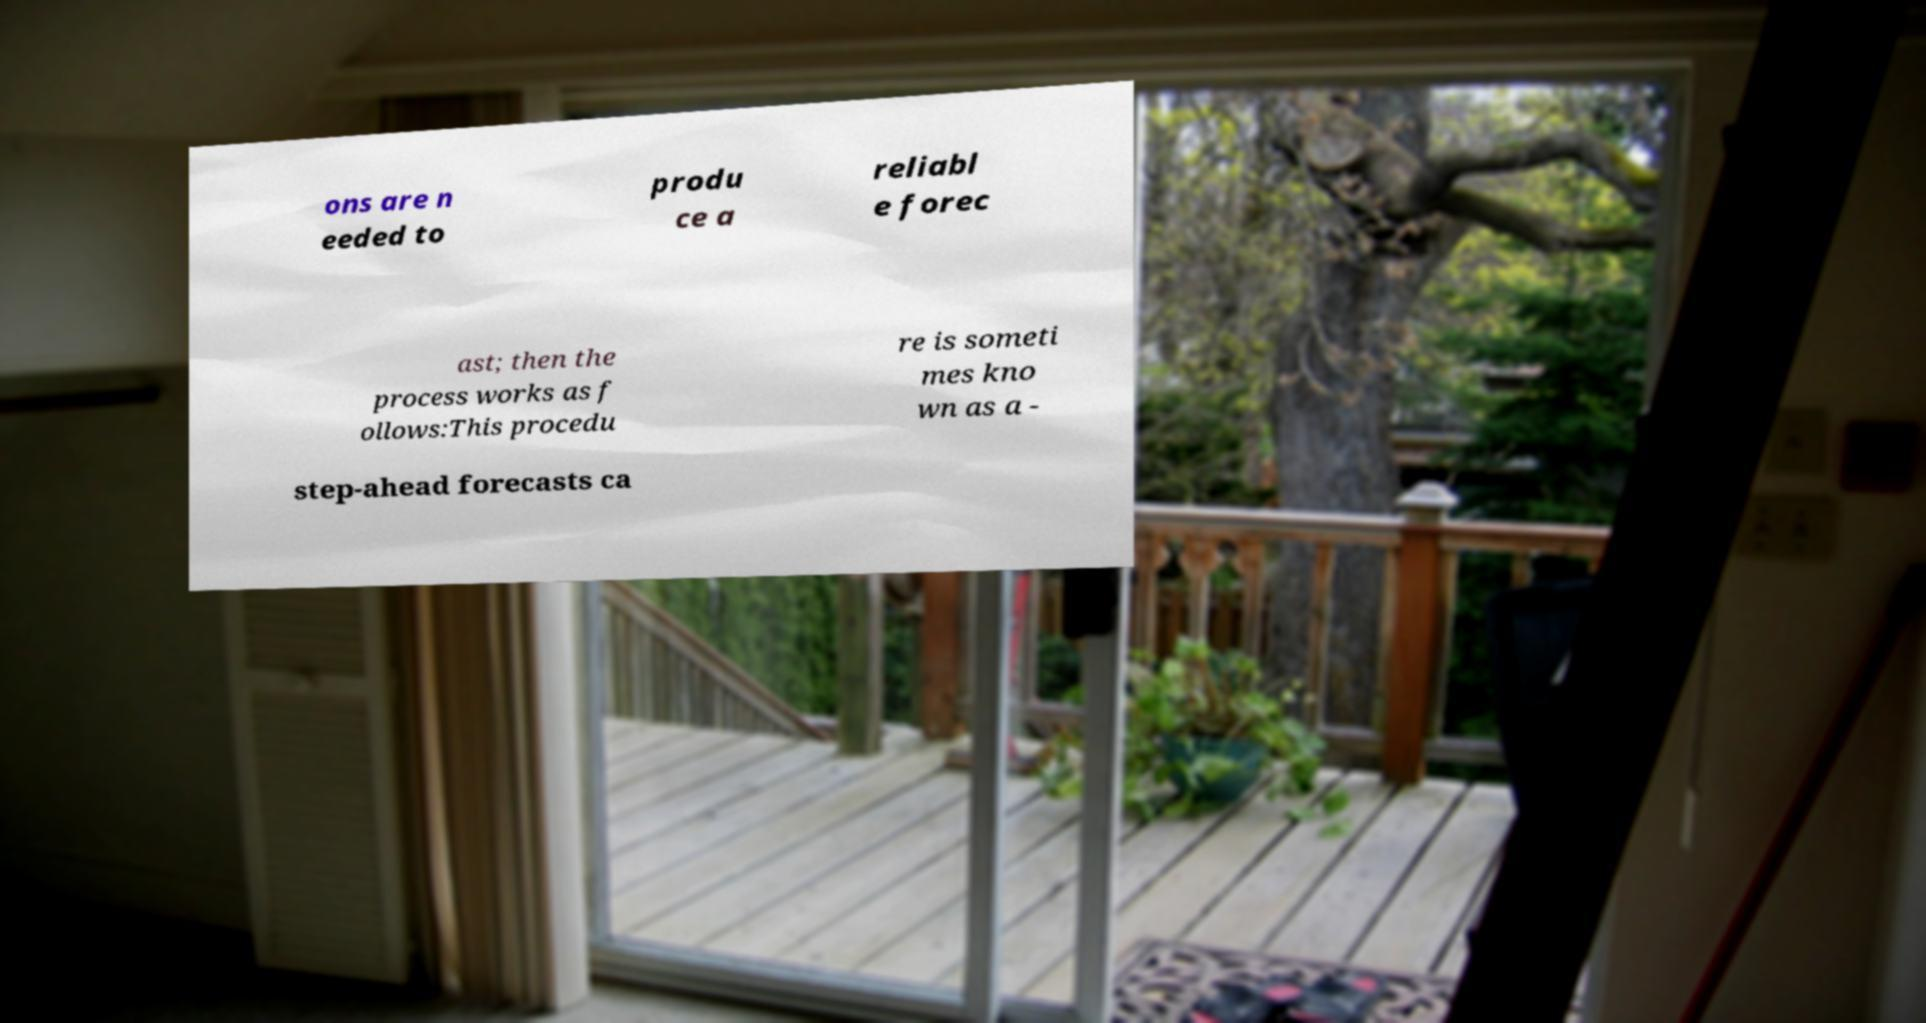Could you assist in decoding the text presented in this image and type it out clearly? ons are n eeded to produ ce a reliabl e forec ast; then the process works as f ollows:This procedu re is someti mes kno wn as a - step-ahead forecasts ca 